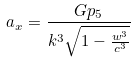<formula> <loc_0><loc_0><loc_500><loc_500>a _ { x } = \frac { G p _ { 5 } } { k ^ { 3 } \sqrt { 1 - \frac { w ^ { 3 } } { c ^ { 3 } } } }</formula> 